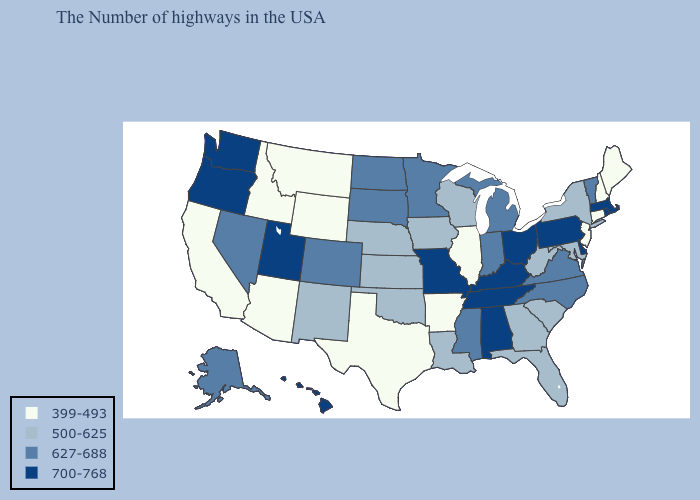Does Alaska have the lowest value in the West?
Keep it brief. No. What is the value of Missouri?
Give a very brief answer. 700-768. Does the first symbol in the legend represent the smallest category?
Short answer required. Yes. Does Missouri have the lowest value in the MidWest?
Be succinct. No. What is the value of Alaska?
Quick response, please. 627-688. What is the value of Delaware?
Keep it brief. 700-768. Name the states that have a value in the range 627-688?
Quick response, please. Vermont, Virginia, North Carolina, Michigan, Indiana, Mississippi, Minnesota, South Dakota, North Dakota, Colorado, Nevada, Alaska. Among the states that border Texas , does Arkansas have the lowest value?
Answer briefly. Yes. Name the states that have a value in the range 627-688?
Keep it brief. Vermont, Virginia, North Carolina, Michigan, Indiana, Mississippi, Minnesota, South Dakota, North Dakota, Colorado, Nevada, Alaska. Name the states that have a value in the range 700-768?
Concise answer only. Massachusetts, Rhode Island, Delaware, Pennsylvania, Ohio, Kentucky, Alabama, Tennessee, Missouri, Utah, Washington, Oregon, Hawaii. Does Oregon have the lowest value in the West?
Concise answer only. No. Does Rhode Island have the lowest value in the USA?
Short answer required. No. Among the states that border Rhode Island , does Connecticut have the highest value?
Give a very brief answer. No. How many symbols are there in the legend?
Concise answer only. 4. How many symbols are there in the legend?
Quick response, please. 4. 